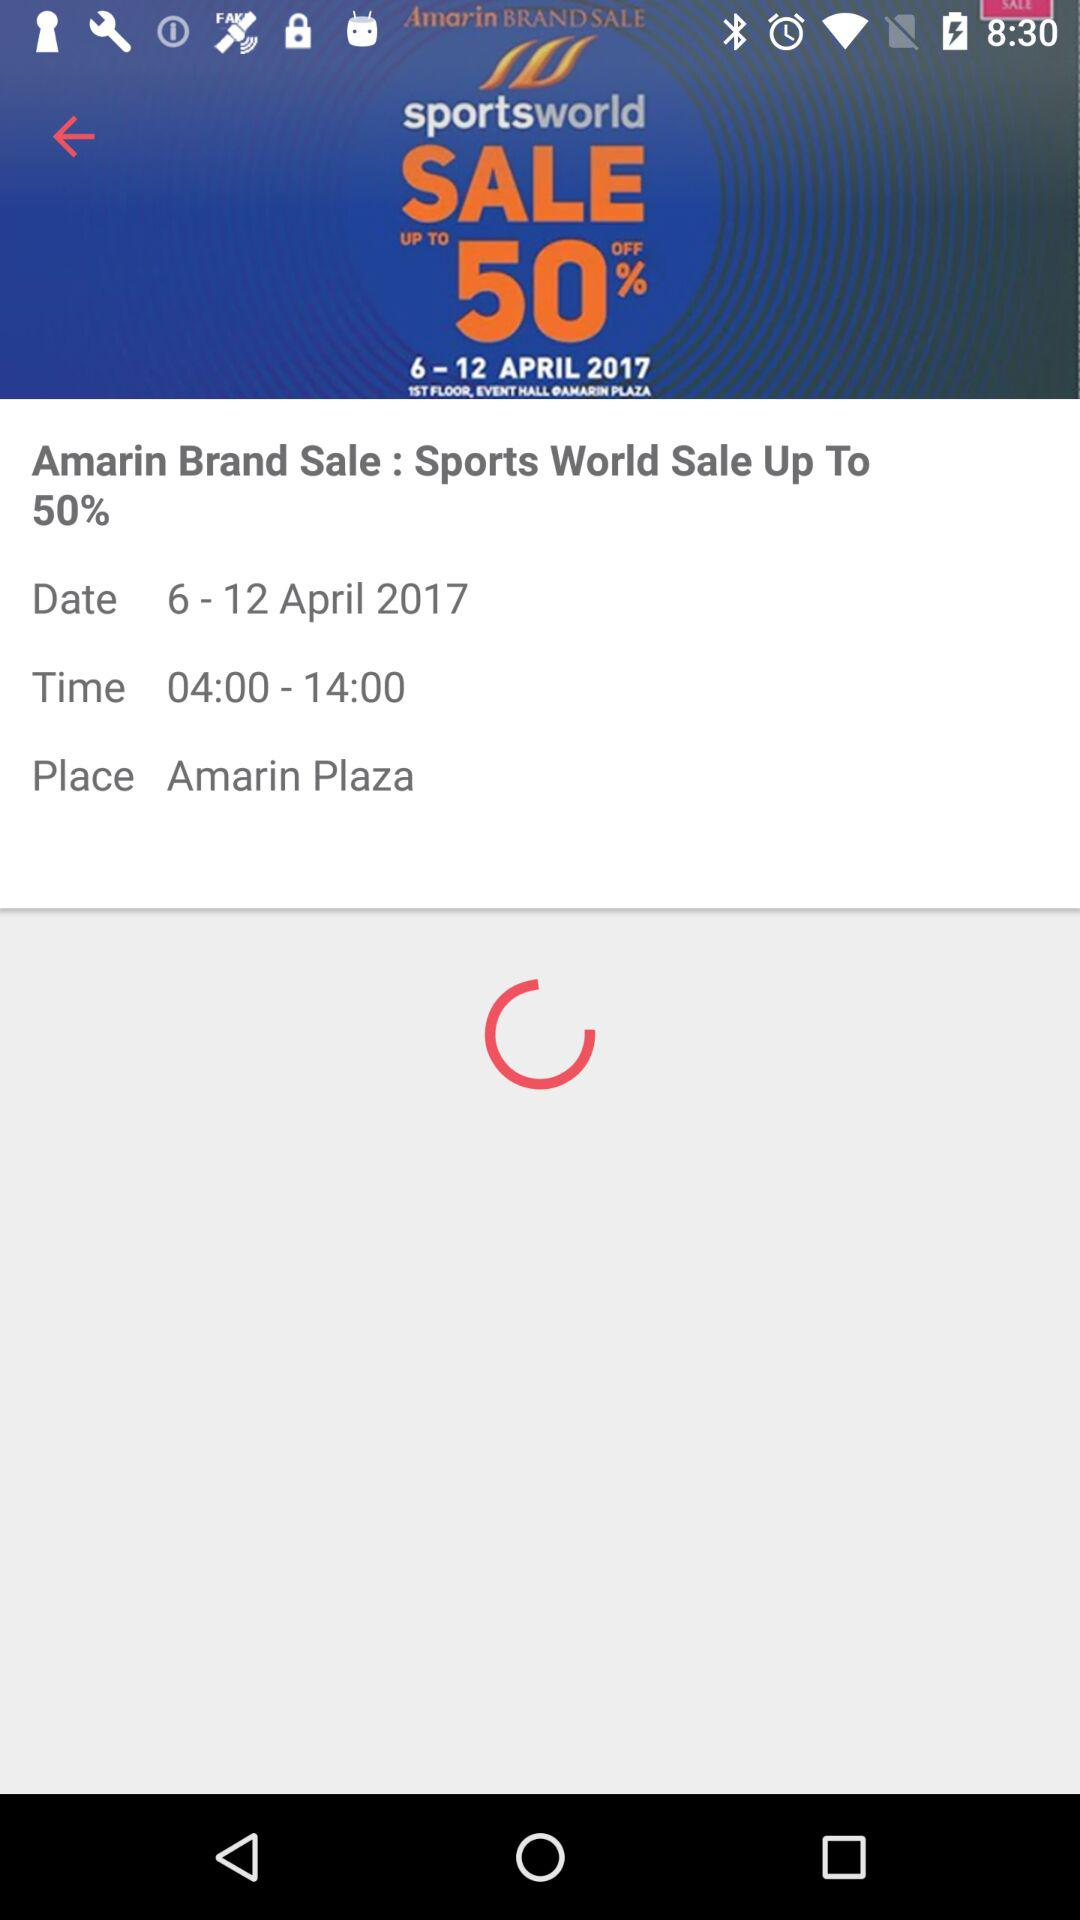Which day of the week does April 6, 2017, fall on?
When the provided information is insufficient, respond with <no answer>. <no answer> 